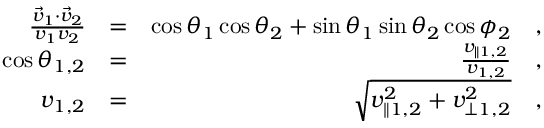Convert formula to latex. <formula><loc_0><loc_0><loc_500><loc_500>\begin{array} { r l r } { \frac { \vec { v } _ { 1 } \cdot \vec { v } _ { 2 } } { v _ { 1 } v _ { 2 } } } & { = } & { \cos \theta _ { 1 } \cos \theta _ { 2 } + \sin \theta _ { 1 } \sin \theta _ { 2 } \cos \phi _ { 2 } \quad , } \\ { \cos \theta _ { 1 , 2 } } & { = } & { \frac { v _ { \| 1 , 2 } } { v _ { 1 , 2 } } \quad , } \\ { v _ { 1 , 2 } } & { = } & { \sqrt { v _ { \| 1 , 2 } ^ { 2 } + v _ { \perp 1 , 2 } ^ { 2 } } \quad , } \end{array}</formula> 